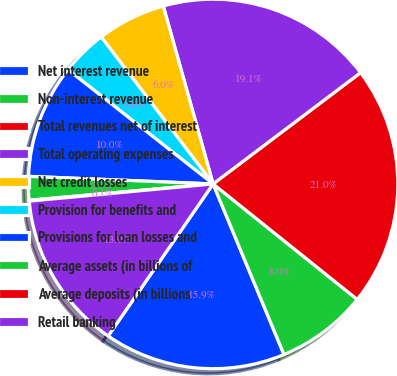Convert chart to OTSL. <chart><loc_0><loc_0><loc_500><loc_500><pie_chart><fcel>Net interest revenue<fcel>Non-interest revenue<fcel>Total revenues net of interest<fcel>Total operating expenses<fcel>Net credit losses<fcel>Provision for benefits and<fcel>Provisions for loan losses and<fcel>Average assets (in billions of<fcel>Average deposits (in billions<fcel>Retail banking<nl><fcel>15.88%<fcel>7.98%<fcel>21.04%<fcel>19.06%<fcel>6.01%<fcel>4.03%<fcel>9.96%<fcel>2.06%<fcel>0.08%<fcel>13.9%<nl></chart> 